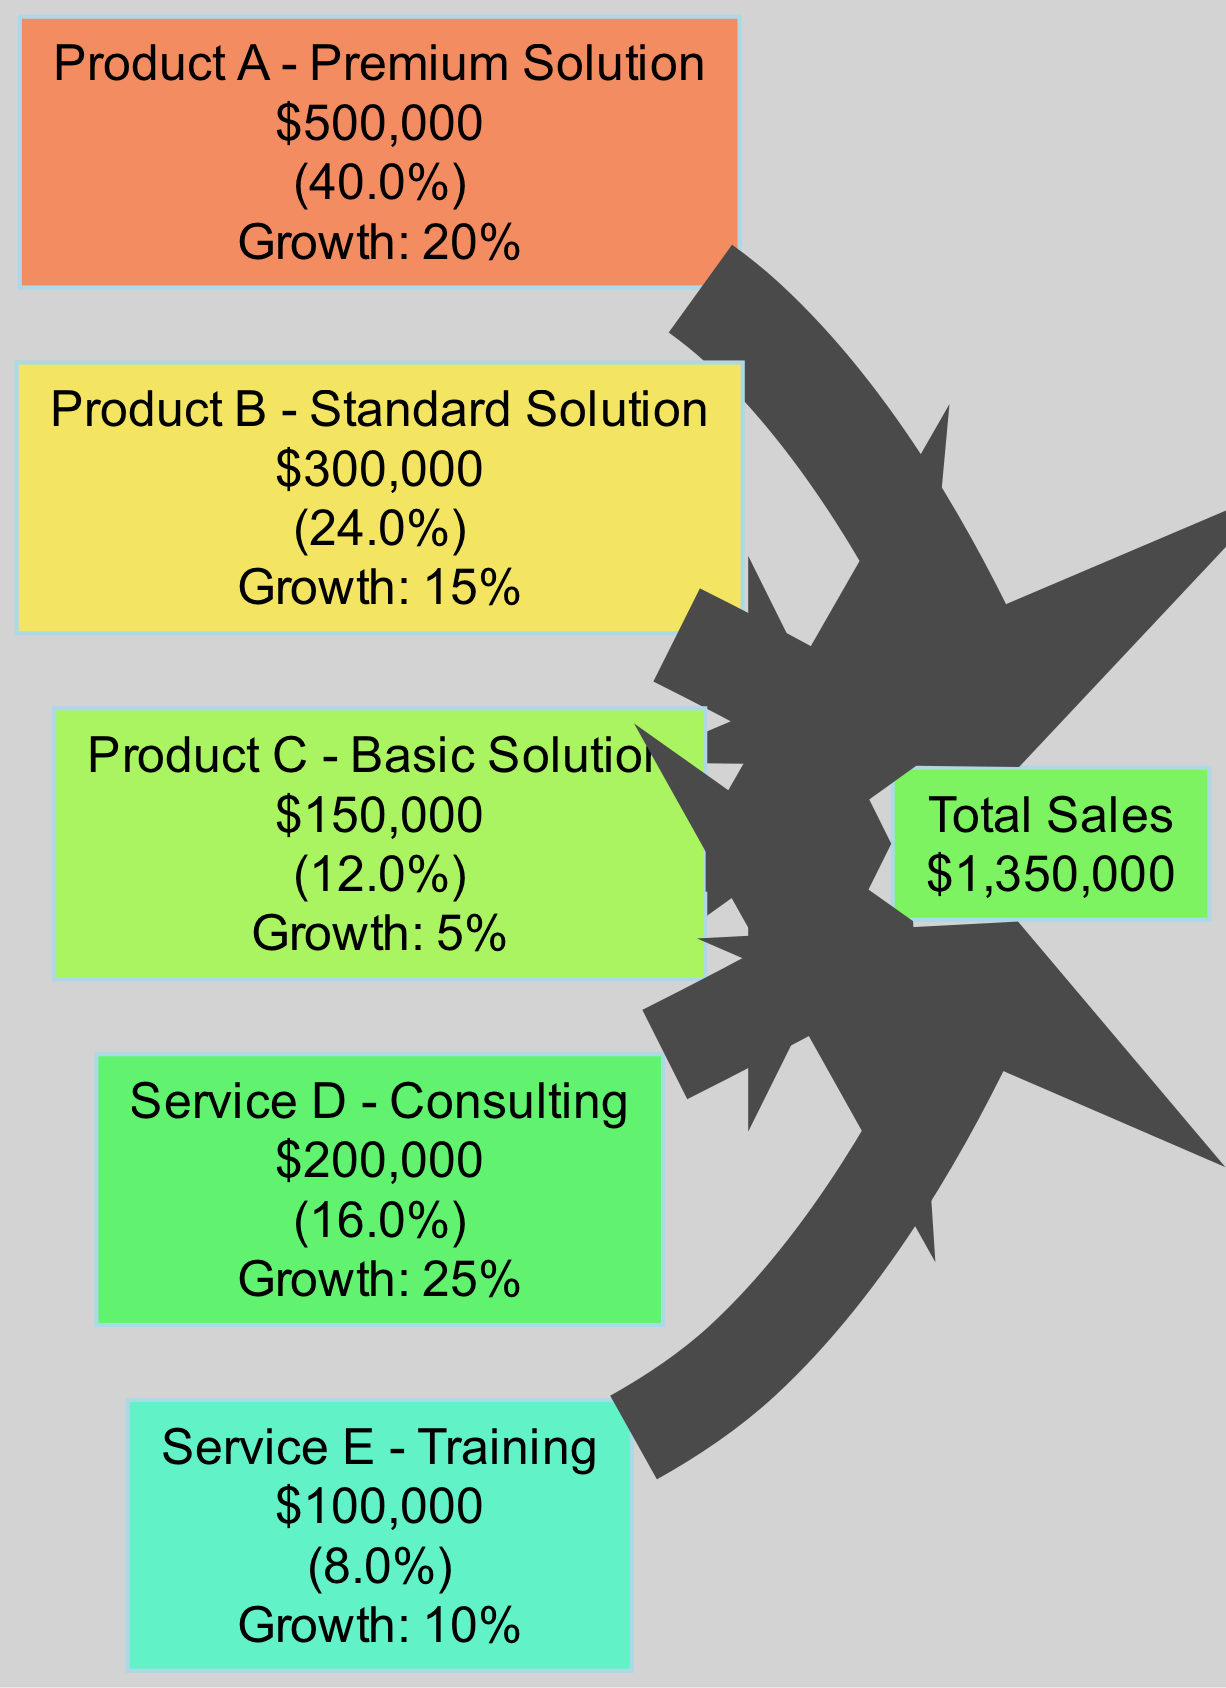What is the value of Product A - Premium Solution? The diagram lists the sources of revenue, and specifically for Product A - Premium Solution, the value is mentioned directly next to its name in the node. The value shown is 500,000.
Answer: 500,000 What percentage contribution does Service E - Training make to Total Sales? To determine the percentage contribution of Service E - Training, we note its value of 100,000 and calculate its contribution to the total sales value of 1,350,000 by applying the formula (100,000 / 1,350,000) * 100, which results in approximately 7.4%.
Answer: 7.4% Which product or service has the highest growth trend? The growth trends section lists the growth rates for each product and service. By comparing these figures, we find that Service D - Consulting has the highest growth rate at 25%.
Answer: Service D - Consulting How many total revenue sources are depicted in the diagram? The diagram includes a list of sources for revenue, counting them gives us a total of five sources: three products and two services.
Answer: 5 What is the growth rate of Product B - Standard Solution? The growth rate information in the diagram indicates that Product B - Standard Solution has a growth statistic associated with it. Specifically, it states that its growth rate is 15%.
Answer: 15% Which source has the lowest value among the products and services? Reviewing the values, we see that Product C - Basic Solution has the lowest value at 150,000, making it the minimal contributor among the listed sources.
Answer: Product C - Basic Solution How does the contribution of Product A - Premium Solution compare to that of Service D - Consulting? From the source values, Product A - Premium Solution contributes 500,000, while Service D - Consulting contributes 200,000. Therefore, Product A contributes significantly more than Service D.
Answer: Product A - Premium Solution contributes more What is the total sales value depicted in the diagram? The targets section of the diagram clearly states the total sales value as 1,350,000. This is the overarching figure representing all revenue sources combined.
Answer: 1,350,000 Which source has a growth trend of 5%? By examining the growth trends data, we can see that Product C - Basic Solution has a growth percentage of 5%, making it the source with the lowest growth.
Answer: Product C - Basic Solution 